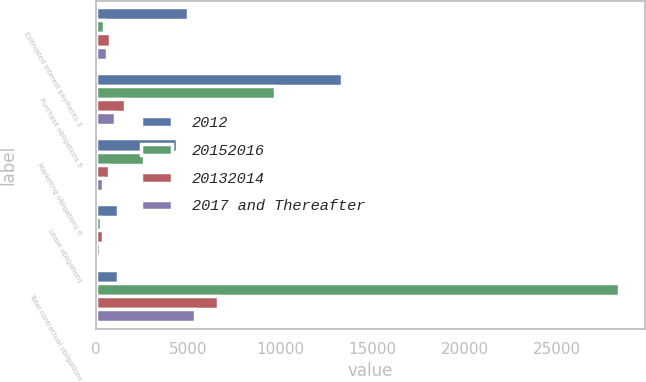<chart> <loc_0><loc_0><loc_500><loc_500><stacked_bar_chart><ecel><fcel>Estimated interest payments 3<fcel>Purchase obligations 5<fcel>Marketing obligations 6<fcel>Lease obligations<fcel>Total contractual obligations<nl><fcel>2012<fcel>5007<fcel>13357<fcel>4389<fcel>1213<fcel>1213<nl><fcel>20152016<fcel>431<fcel>9741<fcel>2600<fcel>282<fcel>28325<nl><fcel>20132014<fcel>784<fcel>1611<fcel>736<fcel>387<fcel>6625<nl><fcel>2017 and Thereafter<fcel>633<fcel>1035<fcel>421<fcel>226<fcel>5391<nl></chart> 